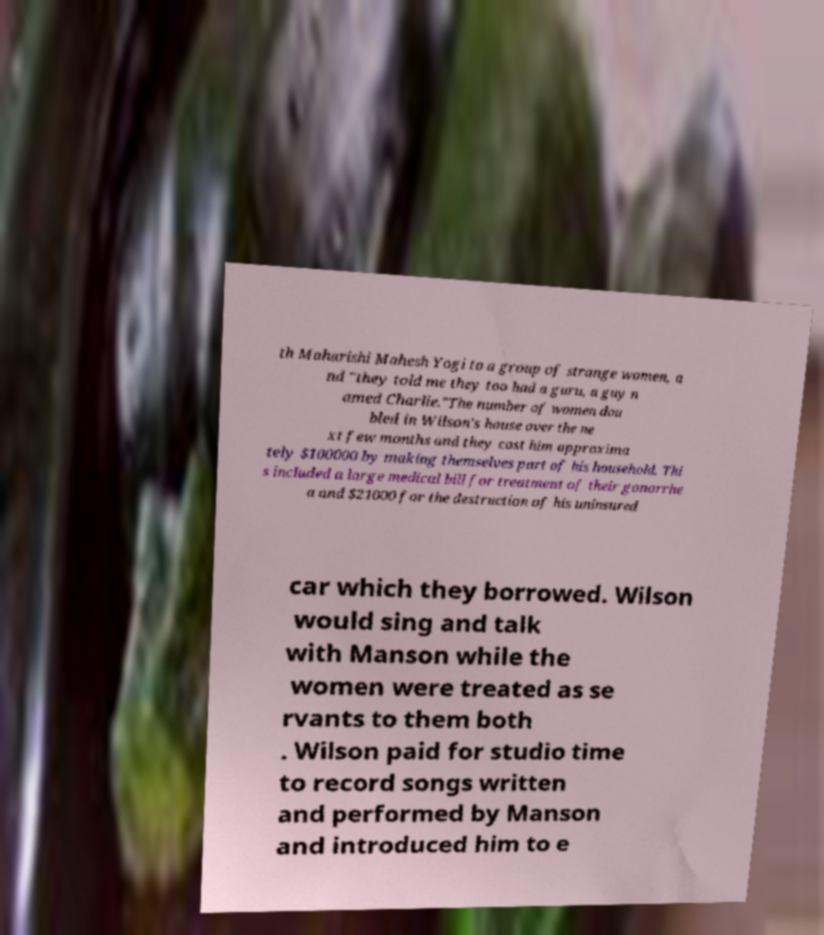Can you read and provide the text displayed in the image?This photo seems to have some interesting text. Can you extract and type it out for me? th Maharishi Mahesh Yogi to a group of strange women, a nd "they told me they too had a guru, a guy n amed Charlie."The number of women dou bled in Wilson's house over the ne xt few months and they cost him approxima tely $100000 by making themselves part of his household. Thi s included a large medical bill for treatment of their gonorrhe a and $21000 for the destruction of his uninsured car which they borrowed. Wilson would sing and talk with Manson while the women were treated as se rvants to them both . Wilson paid for studio time to record songs written and performed by Manson and introduced him to e 